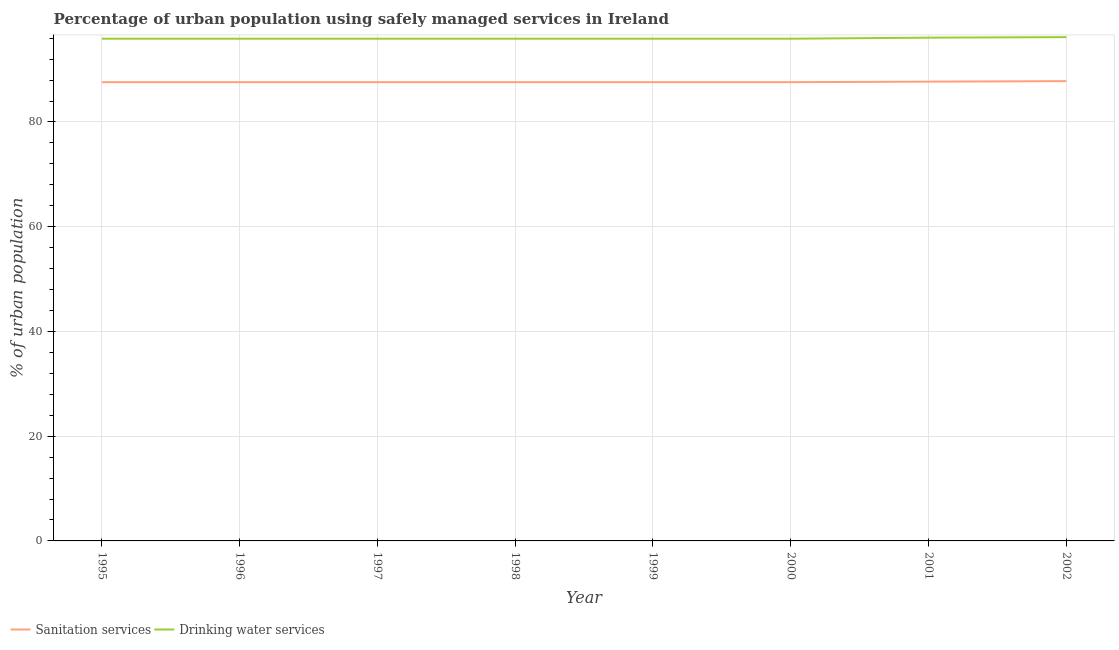How many different coloured lines are there?
Keep it short and to the point. 2. Does the line corresponding to percentage of urban population who used sanitation services intersect with the line corresponding to percentage of urban population who used drinking water services?
Provide a succinct answer. No. What is the percentage of urban population who used drinking water services in 1999?
Your response must be concise. 95.9. Across all years, what is the maximum percentage of urban population who used sanitation services?
Offer a very short reply. 87.8. Across all years, what is the minimum percentage of urban population who used sanitation services?
Your answer should be very brief. 87.6. In which year was the percentage of urban population who used sanitation services maximum?
Keep it short and to the point. 2002. What is the total percentage of urban population who used sanitation services in the graph?
Ensure brevity in your answer.  701.1. What is the difference between the percentage of urban population who used sanitation services in 1996 and the percentage of urban population who used drinking water services in 1995?
Ensure brevity in your answer.  -8.3. What is the average percentage of urban population who used drinking water services per year?
Provide a short and direct response. 95.96. In the year 1996, what is the difference between the percentage of urban population who used sanitation services and percentage of urban population who used drinking water services?
Offer a terse response. -8.3. In how many years, is the percentage of urban population who used drinking water services greater than 80 %?
Offer a terse response. 8. Is the difference between the percentage of urban population who used sanitation services in 1997 and 1999 greater than the difference between the percentage of urban population who used drinking water services in 1997 and 1999?
Keep it short and to the point. No. What is the difference between the highest and the second highest percentage of urban population who used sanitation services?
Give a very brief answer. 0.1. What is the difference between the highest and the lowest percentage of urban population who used sanitation services?
Your response must be concise. 0.2. Is the sum of the percentage of urban population who used sanitation services in 2000 and 2002 greater than the maximum percentage of urban population who used drinking water services across all years?
Give a very brief answer. Yes. How many years are there in the graph?
Ensure brevity in your answer.  8. Are the values on the major ticks of Y-axis written in scientific E-notation?
Offer a very short reply. No. How many legend labels are there?
Your answer should be very brief. 2. What is the title of the graph?
Your answer should be compact. Percentage of urban population using safely managed services in Ireland. Does "Private funds" appear as one of the legend labels in the graph?
Give a very brief answer. No. What is the label or title of the Y-axis?
Your response must be concise. % of urban population. What is the % of urban population of Sanitation services in 1995?
Provide a short and direct response. 87.6. What is the % of urban population of Drinking water services in 1995?
Give a very brief answer. 95.9. What is the % of urban population of Sanitation services in 1996?
Provide a succinct answer. 87.6. What is the % of urban population in Drinking water services in 1996?
Provide a short and direct response. 95.9. What is the % of urban population of Sanitation services in 1997?
Give a very brief answer. 87.6. What is the % of urban population of Drinking water services in 1997?
Provide a short and direct response. 95.9. What is the % of urban population of Sanitation services in 1998?
Offer a terse response. 87.6. What is the % of urban population in Drinking water services in 1998?
Make the answer very short. 95.9. What is the % of urban population in Sanitation services in 1999?
Provide a succinct answer. 87.6. What is the % of urban population in Drinking water services in 1999?
Your answer should be very brief. 95.9. What is the % of urban population in Sanitation services in 2000?
Make the answer very short. 87.6. What is the % of urban population in Drinking water services in 2000?
Keep it short and to the point. 95.9. What is the % of urban population of Sanitation services in 2001?
Offer a terse response. 87.7. What is the % of urban population in Drinking water services in 2001?
Make the answer very short. 96.1. What is the % of urban population in Sanitation services in 2002?
Ensure brevity in your answer.  87.8. What is the % of urban population of Drinking water services in 2002?
Offer a terse response. 96.2. Across all years, what is the maximum % of urban population of Sanitation services?
Provide a short and direct response. 87.8. Across all years, what is the maximum % of urban population of Drinking water services?
Your answer should be compact. 96.2. Across all years, what is the minimum % of urban population in Sanitation services?
Give a very brief answer. 87.6. Across all years, what is the minimum % of urban population in Drinking water services?
Give a very brief answer. 95.9. What is the total % of urban population of Sanitation services in the graph?
Keep it short and to the point. 701.1. What is the total % of urban population in Drinking water services in the graph?
Your response must be concise. 767.7. What is the difference between the % of urban population in Sanitation services in 1995 and that in 1997?
Provide a succinct answer. 0. What is the difference between the % of urban population in Drinking water services in 1995 and that in 1997?
Keep it short and to the point. 0. What is the difference between the % of urban population of Sanitation services in 1995 and that in 1998?
Give a very brief answer. 0. What is the difference between the % of urban population in Drinking water services in 1995 and that in 1998?
Give a very brief answer. 0. What is the difference between the % of urban population of Sanitation services in 1995 and that in 2000?
Make the answer very short. 0. What is the difference between the % of urban population in Drinking water services in 1995 and that in 2000?
Give a very brief answer. 0. What is the difference between the % of urban population of Sanitation services in 1995 and that in 2001?
Give a very brief answer. -0.1. What is the difference between the % of urban population in Drinking water services in 1995 and that in 2001?
Offer a very short reply. -0.2. What is the difference between the % of urban population in Sanitation services in 1995 and that in 2002?
Make the answer very short. -0.2. What is the difference between the % of urban population in Drinking water services in 1995 and that in 2002?
Give a very brief answer. -0.3. What is the difference between the % of urban population of Sanitation services in 1996 and that in 1997?
Provide a short and direct response. 0. What is the difference between the % of urban population in Drinking water services in 1996 and that in 1997?
Keep it short and to the point. 0. What is the difference between the % of urban population in Sanitation services in 1996 and that in 2000?
Make the answer very short. 0. What is the difference between the % of urban population in Sanitation services in 1996 and that in 2001?
Your answer should be very brief. -0.1. What is the difference between the % of urban population in Sanitation services in 1996 and that in 2002?
Ensure brevity in your answer.  -0.2. What is the difference between the % of urban population of Sanitation services in 1997 and that in 1998?
Your response must be concise. 0. What is the difference between the % of urban population of Drinking water services in 1997 and that in 1998?
Your response must be concise. 0. What is the difference between the % of urban population of Drinking water services in 1997 and that in 2000?
Your answer should be very brief. 0. What is the difference between the % of urban population in Sanitation services in 1997 and that in 2001?
Make the answer very short. -0.1. What is the difference between the % of urban population in Drinking water services in 1997 and that in 2001?
Your answer should be compact. -0.2. What is the difference between the % of urban population in Drinking water services in 1997 and that in 2002?
Offer a terse response. -0.3. What is the difference between the % of urban population in Sanitation services in 1998 and that in 1999?
Your answer should be compact. 0. What is the difference between the % of urban population of Drinking water services in 1998 and that in 2000?
Offer a terse response. 0. What is the difference between the % of urban population in Sanitation services in 1998 and that in 2001?
Provide a short and direct response. -0.1. What is the difference between the % of urban population in Sanitation services in 1998 and that in 2002?
Keep it short and to the point. -0.2. What is the difference between the % of urban population of Drinking water services in 1998 and that in 2002?
Your answer should be compact. -0.3. What is the difference between the % of urban population of Sanitation services in 1999 and that in 2000?
Your answer should be very brief. 0. What is the difference between the % of urban population of Sanitation services in 1999 and that in 2001?
Your answer should be very brief. -0.1. What is the difference between the % of urban population of Drinking water services in 1999 and that in 2001?
Keep it short and to the point. -0.2. What is the difference between the % of urban population of Sanitation services in 1999 and that in 2002?
Make the answer very short. -0.2. What is the difference between the % of urban population in Sanitation services in 2000 and that in 2001?
Your response must be concise. -0.1. What is the difference between the % of urban population in Sanitation services in 2000 and that in 2002?
Provide a short and direct response. -0.2. What is the difference between the % of urban population of Drinking water services in 2000 and that in 2002?
Your answer should be compact. -0.3. What is the difference between the % of urban population of Sanitation services in 2001 and that in 2002?
Offer a terse response. -0.1. What is the difference between the % of urban population of Drinking water services in 2001 and that in 2002?
Offer a terse response. -0.1. What is the difference between the % of urban population in Sanitation services in 1995 and the % of urban population in Drinking water services in 1996?
Make the answer very short. -8.3. What is the difference between the % of urban population of Sanitation services in 1995 and the % of urban population of Drinking water services in 1998?
Ensure brevity in your answer.  -8.3. What is the difference between the % of urban population in Sanitation services in 1995 and the % of urban population in Drinking water services in 2000?
Provide a short and direct response. -8.3. What is the difference between the % of urban population in Sanitation services in 1995 and the % of urban population in Drinking water services in 2002?
Make the answer very short. -8.6. What is the difference between the % of urban population in Sanitation services in 1996 and the % of urban population in Drinking water services in 1997?
Offer a terse response. -8.3. What is the difference between the % of urban population of Sanitation services in 1996 and the % of urban population of Drinking water services in 1998?
Your response must be concise. -8.3. What is the difference between the % of urban population in Sanitation services in 1996 and the % of urban population in Drinking water services in 2001?
Your response must be concise. -8.5. What is the difference between the % of urban population of Sanitation services in 1996 and the % of urban population of Drinking water services in 2002?
Your answer should be very brief. -8.6. What is the difference between the % of urban population of Sanitation services in 1997 and the % of urban population of Drinking water services in 1999?
Make the answer very short. -8.3. What is the difference between the % of urban population in Sanitation services in 1997 and the % of urban population in Drinking water services in 2001?
Provide a succinct answer. -8.5. What is the difference between the % of urban population of Sanitation services in 1997 and the % of urban population of Drinking water services in 2002?
Make the answer very short. -8.6. What is the difference between the % of urban population in Sanitation services in 1998 and the % of urban population in Drinking water services in 1999?
Offer a terse response. -8.3. What is the difference between the % of urban population in Sanitation services in 1998 and the % of urban population in Drinking water services in 2001?
Make the answer very short. -8.5. What is the difference between the % of urban population in Sanitation services in 1999 and the % of urban population in Drinking water services in 2001?
Give a very brief answer. -8.5. What is the difference between the % of urban population in Sanitation services in 2000 and the % of urban population in Drinking water services in 2001?
Ensure brevity in your answer.  -8.5. What is the average % of urban population of Sanitation services per year?
Your answer should be very brief. 87.64. What is the average % of urban population of Drinking water services per year?
Ensure brevity in your answer.  95.96. In the year 1996, what is the difference between the % of urban population of Sanitation services and % of urban population of Drinking water services?
Make the answer very short. -8.3. In the year 1999, what is the difference between the % of urban population in Sanitation services and % of urban population in Drinking water services?
Keep it short and to the point. -8.3. In the year 2000, what is the difference between the % of urban population of Sanitation services and % of urban population of Drinking water services?
Your answer should be compact. -8.3. In the year 2001, what is the difference between the % of urban population of Sanitation services and % of urban population of Drinking water services?
Your answer should be compact. -8.4. What is the ratio of the % of urban population in Sanitation services in 1995 to that in 1996?
Offer a terse response. 1. What is the ratio of the % of urban population of Drinking water services in 1995 to that in 1996?
Offer a very short reply. 1. What is the ratio of the % of urban population of Sanitation services in 1995 to that in 1998?
Provide a short and direct response. 1. What is the ratio of the % of urban population in Sanitation services in 1995 to that in 1999?
Ensure brevity in your answer.  1. What is the ratio of the % of urban population in Sanitation services in 1995 to that in 2000?
Make the answer very short. 1. What is the ratio of the % of urban population of Sanitation services in 1995 to that in 2002?
Provide a short and direct response. 1. What is the ratio of the % of urban population in Sanitation services in 1996 to that in 1997?
Offer a terse response. 1. What is the ratio of the % of urban population of Drinking water services in 1996 to that in 1999?
Give a very brief answer. 1. What is the ratio of the % of urban population of Drinking water services in 1996 to that in 2000?
Offer a very short reply. 1. What is the ratio of the % of urban population of Sanitation services in 1996 to that in 2001?
Offer a very short reply. 1. What is the ratio of the % of urban population of Drinking water services in 1996 to that in 2001?
Provide a succinct answer. 1. What is the ratio of the % of urban population of Sanitation services in 1996 to that in 2002?
Provide a succinct answer. 1. What is the ratio of the % of urban population in Drinking water services in 1996 to that in 2002?
Ensure brevity in your answer.  1. What is the ratio of the % of urban population of Drinking water services in 1997 to that in 1998?
Offer a terse response. 1. What is the ratio of the % of urban population of Sanitation services in 1997 to that in 1999?
Ensure brevity in your answer.  1. What is the ratio of the % of urban population of Drinking water services in 1997 to that in 1999?
Offer a terse response. 1. What is the ratio of the % of urban population in Sanitation services in 1997 to that in 2000?
Provide a succinct answer. 1. What is the ratio of the % of urban population of Sanitation services in 1997 to that in 2002?
Offer a very short reply. 1. What is the ratio of the % of urban population of Sanitation services in 1998 to that in 1999?
Provide a succinct answer. 1. What is the ratio of the % of urban population in Drinking water services in 1998 to that in 1999?
Keep it short and to the point. 1. What is the ratio of the % of urban population of Sanitation services in 1998 to that in 2000?
Provide a short and direct response. 1. What is the ratio of the % of urban population in Sanitation services in 1998 to that in 2001?
Make the answer very short. 1. What is the ratio of the % of urban population in Drinking water services in 1998 to that in 2001?
Your response must be concise. 1. What is the ratio of the % of urban population of Drinking water services in 1998 to that in 2002?
Your answer should be compact. 1. What is the ratio of the % of urban population in Sanitation services in 1999 to that in 2000?
Give a very brief answer. 1. What is the ratio of the % of urban population of Sanitation services in 1999 to that in 2001?
Your answer should be compact. 1. What is the ratio of the % of urban population in Drinking water services in 2000 to that in 2001?
Your answer should be very brief. 1. What is the ratio of the % of urban population of Sanitation services in 2000 to that in 2002?
Your response must be concise. 1. What is the difference between the highest and the second highest % of urban population of Sanitation services?
Offer a very short reply. 0.1. What is the difference between the highest and the second highest % of urban population in Drinking water services?
Offer a very short reply. 0.1. What is the difference between the highest and the lowest % of urban population in Sanitation services?
Ensure brevity in your answer.  0.2. What is the difference between the highest and the lowest % of urban population of Drinking water services?
Give a very brief answer. 0.3. 